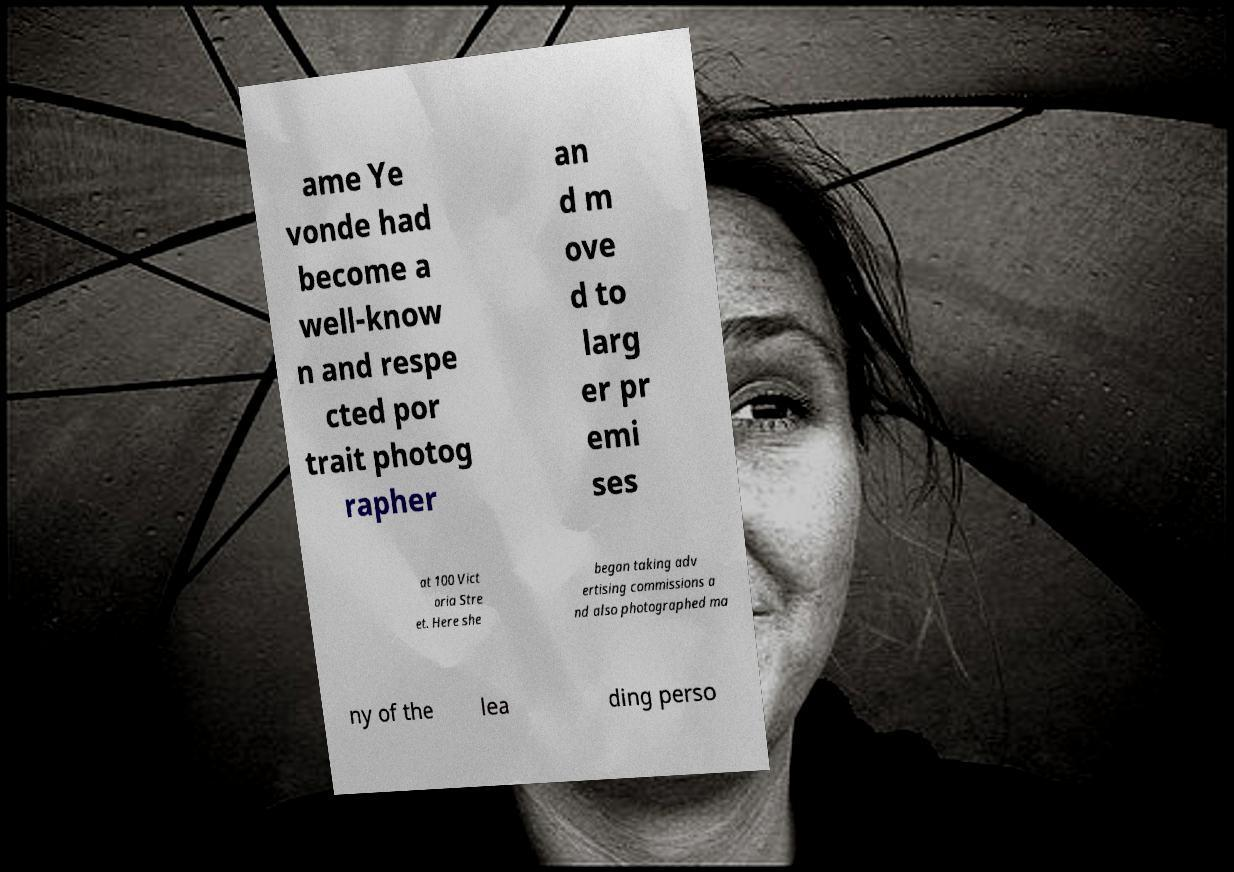Could you assist in decoding the text presented in this image and type it out clearly? ame Ye vonde had become a well-know n and respe cted por trait photog rapher an d m ove d to larg er pr emi ses at 100 Vict oria Stre et. Here she began taking adv ertising commissions a nd also photographed ma ny of the lea ding perso 